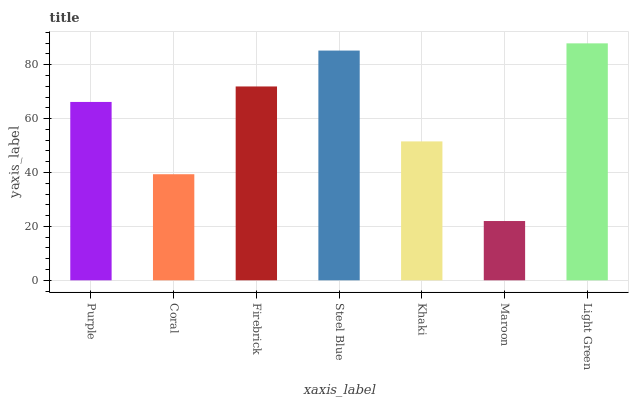Is Maroon the minimum?
Answer yes or no. Yes. Is Light Green the maximum?
Answer yes or no. Yes. Is Coral the minimum?
Answer yes or no. No. Is Coral the maximum?
Answer yes or no. No. Is Purple greater than Coral?
Answer yes or no. Yes. Is Coral less than Purple?
Answer yes or no. Yes. Is Coral greater than Purple?
Answer yes or no. No. Is Purple less than Coral?
Answer yes or no. No. Is Purple the high median?
Answer yes or no. Yes. Is Purple the low median?
Answer yes or no. Yes. Is Steel Blue the high median?
Answer yes or no. No. Is Coral the low median?
Answer yes or no. No. 